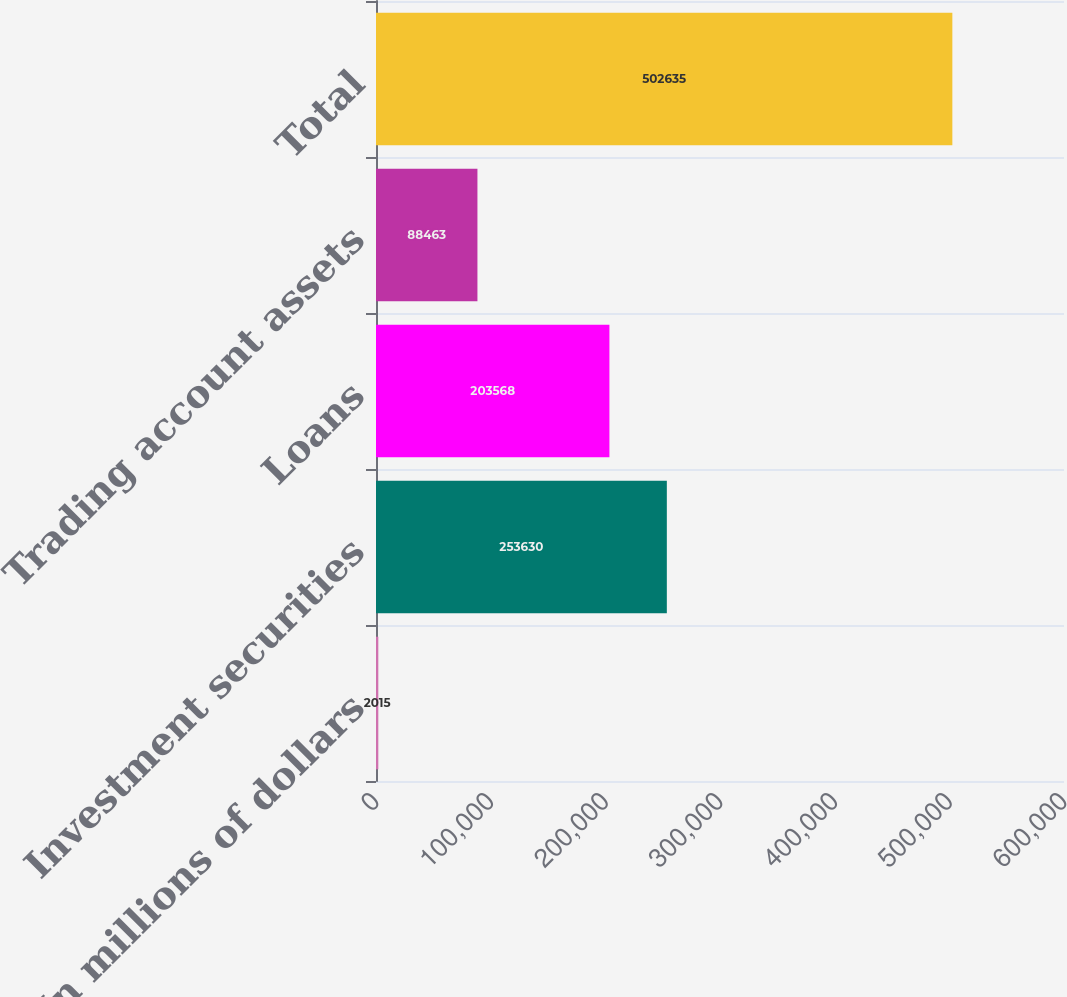Convert chart to OTSL. <chart><loc_0><loc_0><loc_500><loc_500><bar_chart><fcel>In millions of dollars<fcel>Investment securities<fcel>Loans<fcel>Trading account assets<fcel>Total<nl><fcel>2015<fcel>253630<fcel>203568<fcel>88463<fcel>502635<nl></chart> 